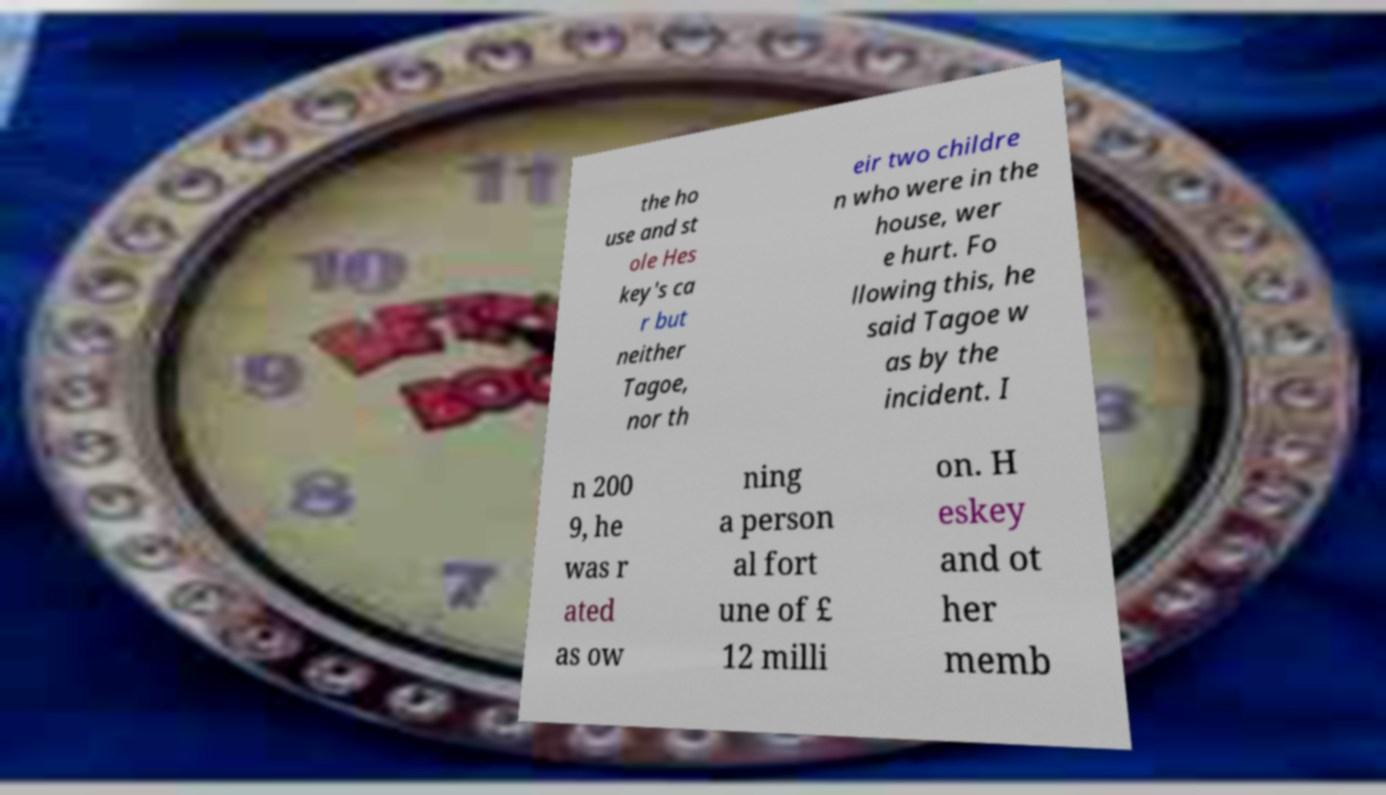Please identify and transcribe the text found in this image. the ho use and st ole Hes key's ca r but neither Tagoe, nor th eir two childre n who were in the house, wer e hurt. Fo llowing this, he said Tagoe w as by the incident. I n 200 9, he was r ated as ow ning a person al fort une of £ 12 milli on. H eskey and ot her memb 